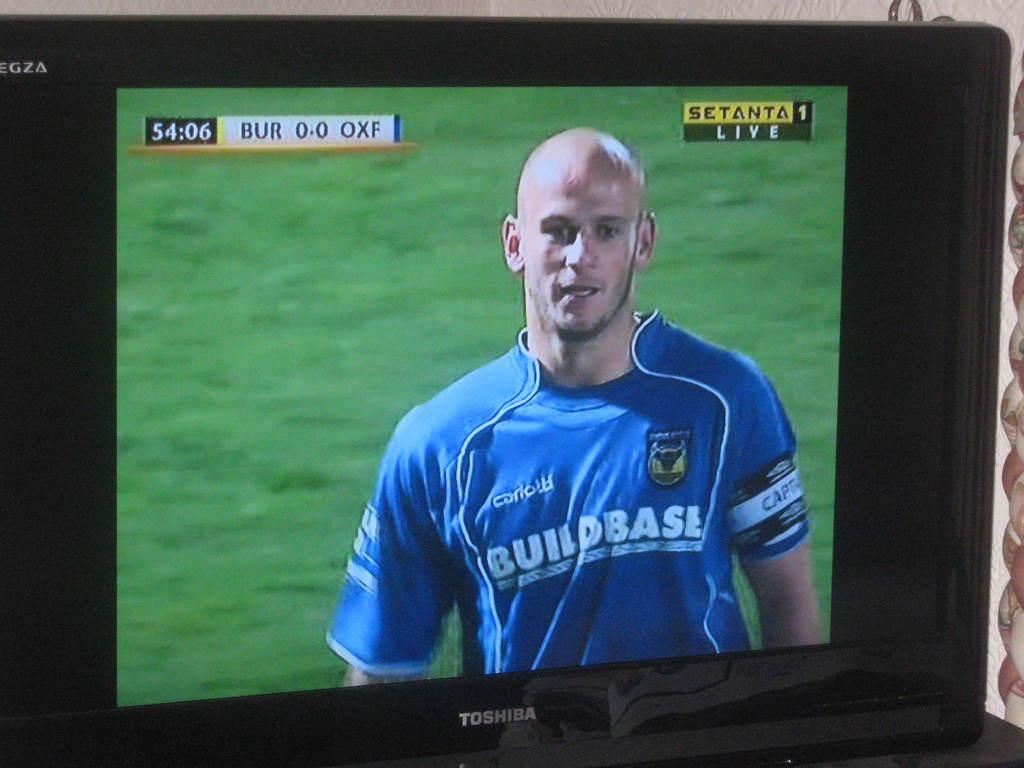<image>
Offer a succinct explanation of the picture presented. On a tv screen is a man wearing a blue shirt labeled BuildBase. 